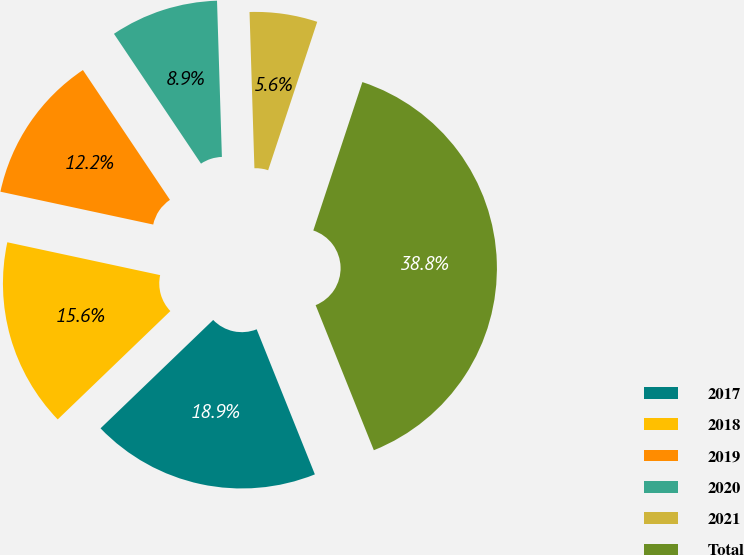Convert chart to OTSL. <chart><loc_0><loc_0><loc_500><loc_500><pie_chart><fcel>2017<fcel>2018<fcel>2019<fcel>2020<fcel>2021<fcel>Total<nl><fcel>18.88%<fcel>15.56%<fcel>12.23%<fcel>8.9%<fcel>5.58%<fcel>38.84%<nl></chart> 